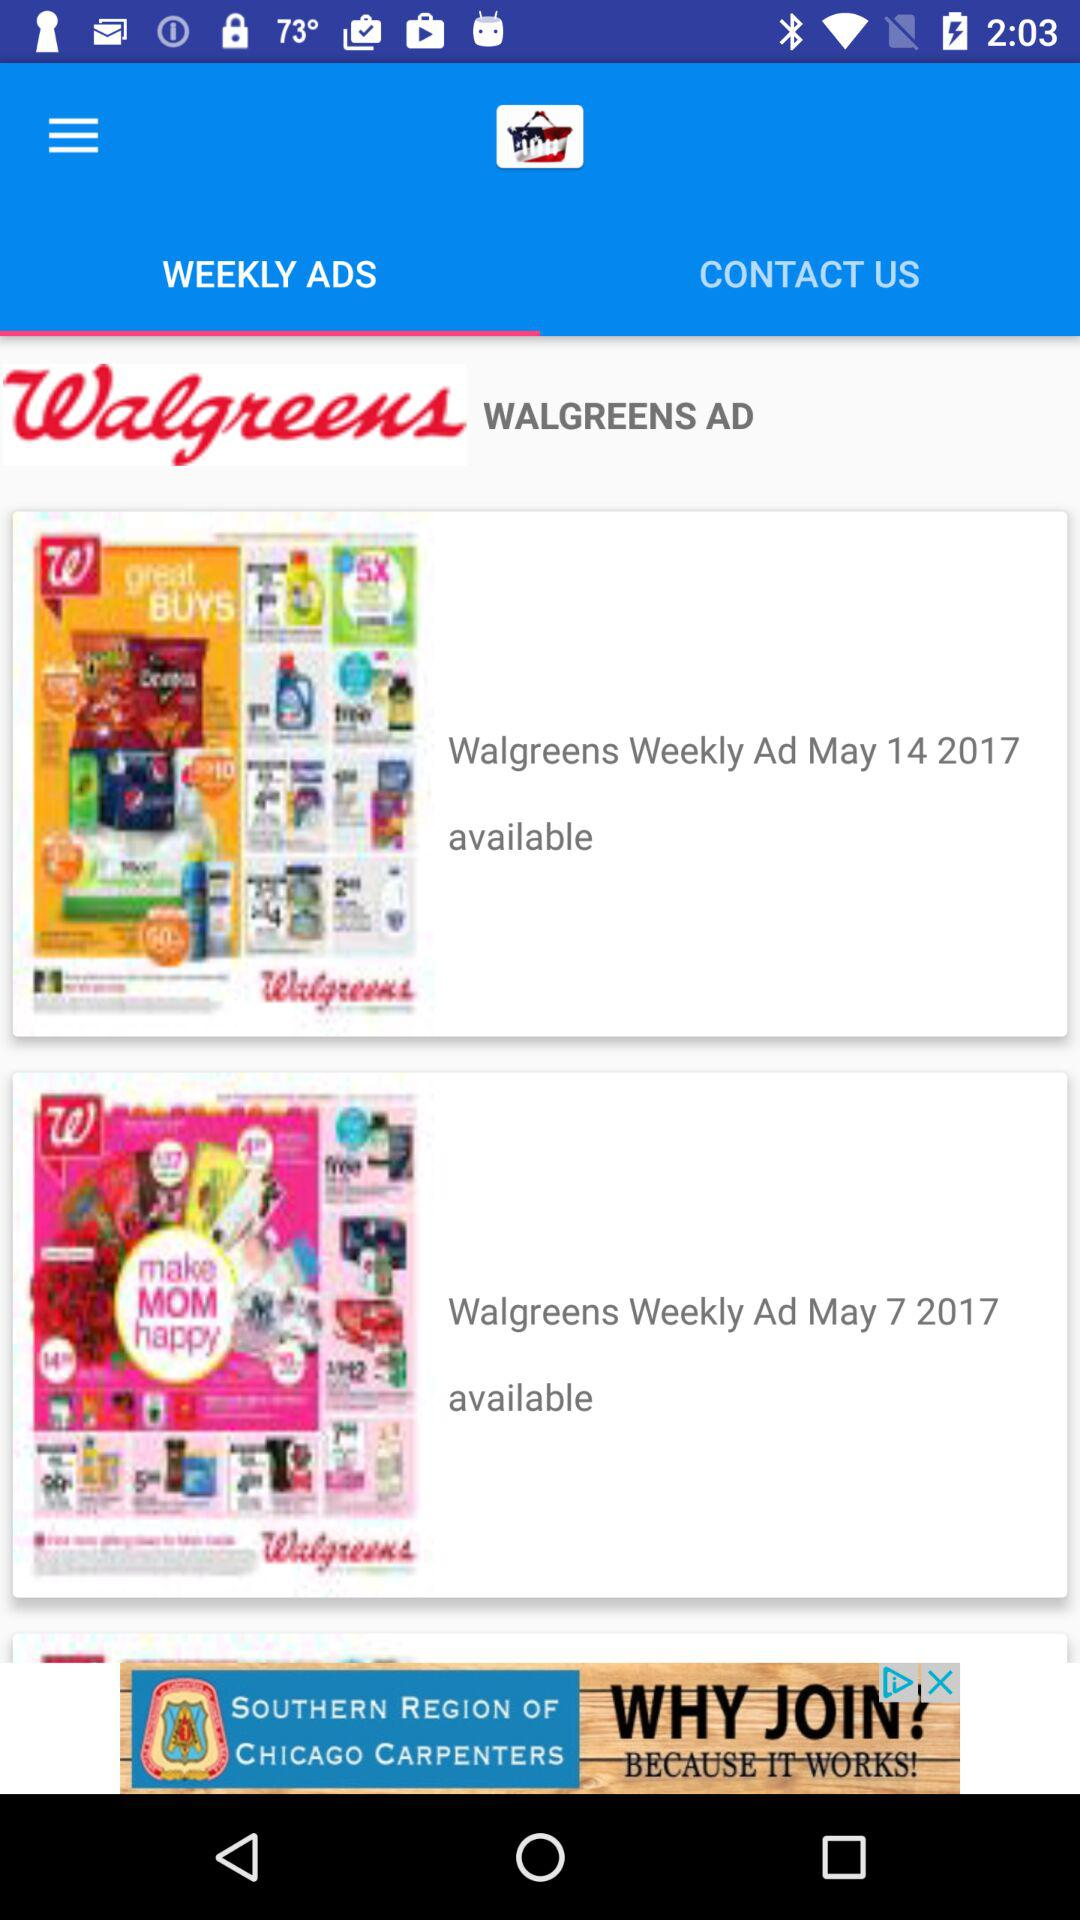Which tab has been selected? The selected tab is "WEEKLY ADS". 